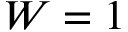Convert formula to latex. <formula><loc_0><loc_0><loc_500><loc_500>W = \boldsymbol 1</formula> 